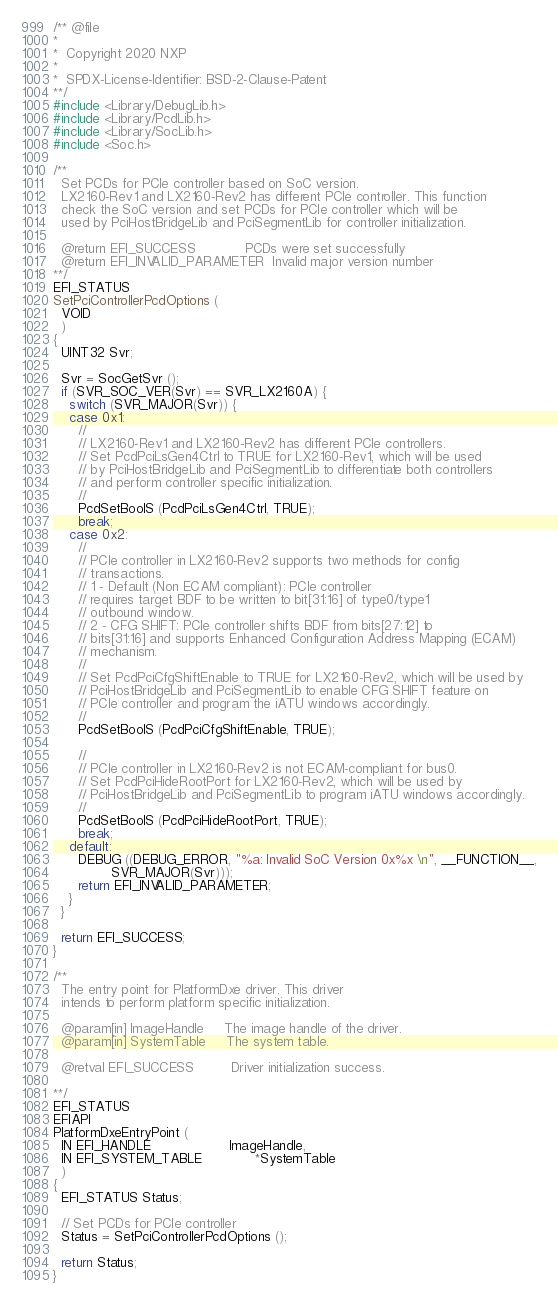<code> <loc_0><loc_0><loc_500><loc_500><_C_>/** @file
*
*  Copyright 2020 NXP
*
*  SPDX-License-Identifier: BSD-2-Clause-Patent
**/
#include <Library/DebugLib.h>
#include <Library/PcdLib.h>
#include <Library/SocLib.h>
#include <Soc.h>

/**
  Set PCDs for PCIe controller based on SoC version.
  LX2160-Rev1 and LX2160-Rev2 has different PCIe controller. This function
  check the SoC version and set PCDs for PCIe controller which will be
  used by PciHostBridgeLib and PciSegmentLib for controller initialization.

  @return EFI_SUCCESS            PCDs were set successfully
  @return EFI_INVALID_PARAMETER  Invalid major version number
**/
EFI_STATUS
SetPciControllerPcdOptions (
  VOID
  )
{
  UINT32 Svr;

  Svr = SocGetSvr ();
  if (SVR_SOC_VER(Svr) == SVR_LX2160A) {
    switch (SVR_MAJOR(Svr)) {
    case 0x1:
      //
      // LX2160-Rev1 and LX2160-Rev2 has different PCIe controllers.
      // Set PcdPciLsGen4Ctrl to TRUE for LX2160-Rev1, which will be used
      // by PciHostBridgeLib and PciSegmentLib to differentiate both controllers
      // and perform controller specific initialization.
      //
      PcdSetBoolS (PcdPciLsGen4Ctrl, TRUE);
      break;
    case 0x2:
      //
      // PCIe controller in LX2160-Rev2 supports two methods for config
      // transactions.
      // 1 - Default (Non ECAM compliant): PCIe controller
      // requires target BDF to be written to bit[31:16] of type0/type1
      // outbound window.
      // 2 - CFG SHIFT: PCIe controller shifts BDF from bits[27:12] to
      // bits[31:16] and supports Enhanced Configuration Address Mapping (ECAM)
      // mechanism.
      //
      // Set PcdPciCfgShiftEnable to TRUE for LX2160-Rev2, which will be used by
      // PciHostBridgeLib and PciSegmentLib to enable CFG SHIFT feature on
      // PCIe controller and program the iATU windows accordingly.
      //
      PcdSetBoolS (PcdPciCfgShiftEnable, TRUE);

      //
      // PCIe controller in LX2160-Rev2 is not ECAM-compliant for bus0.
      // Set PcdPciHideRootPort for LX2160-Rev2, which will be used by
      // PciHostBridgeLib and PciSegmentLib to program iATU windows accordingly.
      //
      PcdSetBoolS (PcdPciHideRootPort, TRUE);
      break;
    default:
      DEBUG ((DEBUG_ERROR, "%a: Invalid SoC Version 0x%x \n", __FUNCTION__,
              SVR_MAJOR(Svr)));
      return EFI_INVALID_PARAMETER;
    }
  }

  return EFI_SUCCESS;
}

/**
  The entry point for PlatformDxe driver. This driver
  intends to perform platform specific initialization.

  @param[in] ImageHandle     The image handle of the driver.
  @param[in] SystemTable     The system table.

  @retval EFI_SUCCESS         Driver initialization success.

**/
EFI_STATUS
EFIAPI
PlatformDxeEntryPoint (
  IN EFI_HANDLE                   ImageHandle,
  IN EFI_SYSTEM_TABLE             *SystemTable
  )
{
  EFI_STATUS Status;

  // Set PCDs for PCIe controller
  Status = SetPciControllerPcdOptions ();

  return Status;
}
</code> 